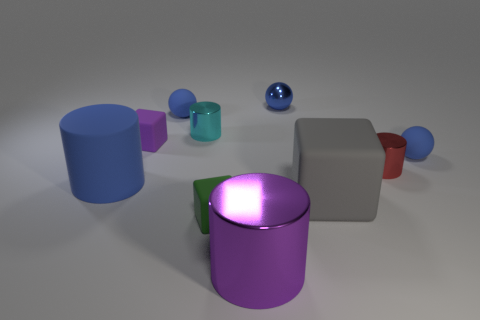Subtract all tiny purple cubes. How many cubes are left? 2 Subtract all red cylinders. How many cylinders are left? 3 Subtract 1 spheres. How many spheres are left? 2 Subtract all green cylinders. Subtract all brown balls. How many cylinders are left? 4 Subtract all blocks. How many objects are left? 7 Add 8 big metallic things. How many big metallic things are left? 9 Add 3 big gray blocks. How many big gray blocks exist? 4 Subtract 0 red blocks. How many objects are left? 10 Subtract all large matte cubes. Subtract all metallic cylinders. How many objects are left? 6 